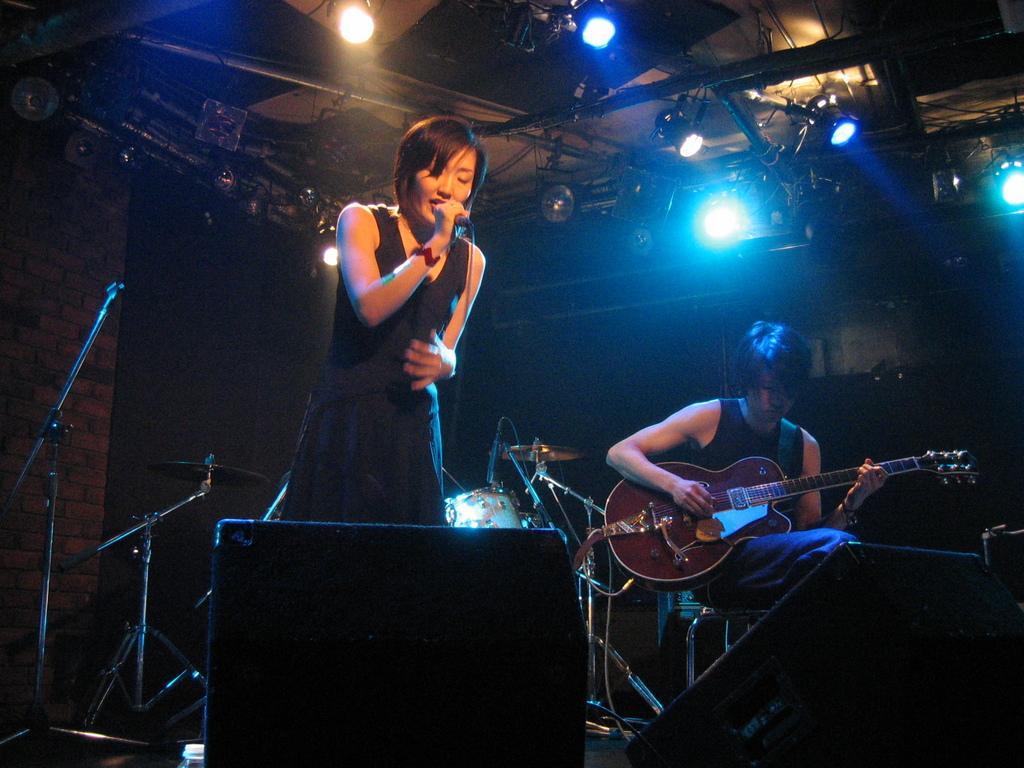Can you describe this image briefly? A lady with black dress is standing and singing. In her hand there is a mic. And there is a man sitting on a chair and playing his guitar. In front of them there are speakers. In the background there are drums and musical instruments. And there is a light. 